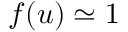Convert formula to latex. <formula><loc_0><loc_0><loc_500><loc_500>f ( u ) \simeq 1</formula> 